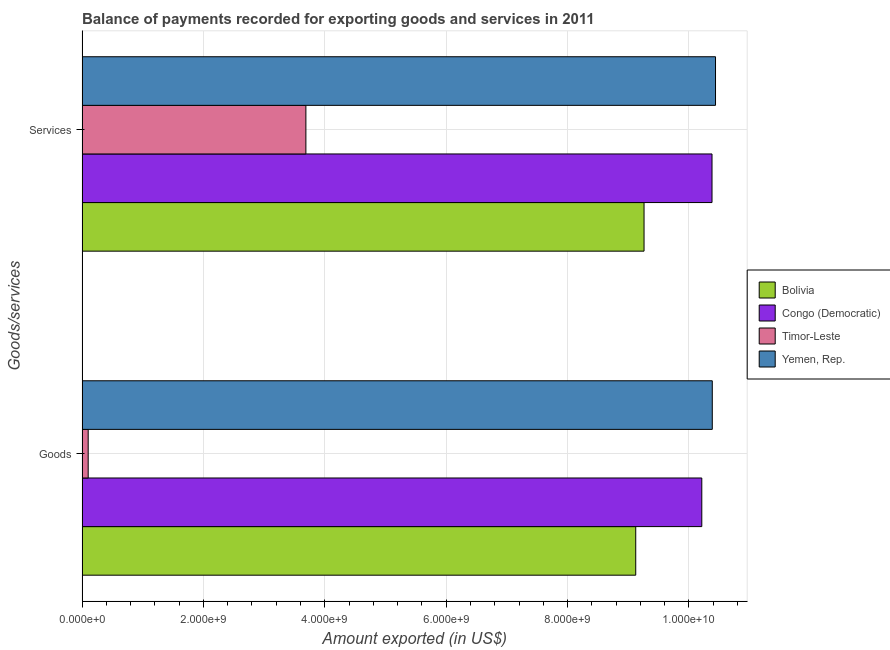How many bars are there on the 1st tick from the top?
Offer a terse response. 4. What is the label of the 2nd group of bars from the top?
Offer a terse response. Goods. What is the amount of services exported in Bolivia?
Ensure brevity in your answer.  9.26e+09. Across all countries, what is the maximum amount of services exported?
Your answer should be very brief. 1.04e+1. Across all countries, what is the minimum amount of services exported?
Your response must be concise. 3.69e+09. In which country was the amount of goods exported maximum?
Your response must be concise. Yemen, Rep. In which country was the amount of services exported minimum?
Offer a terse response. Timor-Leste. What is the total amount of goods exported in the graph?
Your answer should be compact. 2.98e+1. What is the difference between the amount of services exported in Bolivia and that in Timor-Leste?
Offer a terse response. 5.57e+09. What is the difference between the amount of services exported in Yemen, Rep. and the amount of goods exported in Bolivia?
Offer a terse response. 1.31e+09. What is the average amount of services exported per country?
Your response must be concise. 8.44e+09. What is the difference between the amount of services exported and amount of goods exported in Timor-Leste?
Make the answer very short. 3.59e+09. What is the ratio of the amount of services exported in Bolivia to that in Congo (Democratic)?
Your answer should be very brief. 0.89. In how many countries, is the amount of services exported greater than the average amount of services exported taken over all countries?
Make the answer very short. 3. What does the 4th bar from the top in Services represents?
Offer a very short reply. Bolivia. What does the 4th bar from the bottom in Goods represents?
Your answer should be very brief. Yemen, Rep. What is the difference between two consecutive major ticks on the X-axis?
Offer a terse response. 2.00e+09. Where does the legend appear in the graph?
Make the answer very short. Center right. How are the legend labels stacked?
Your answer should be compact. Vertical. What is the title of the graph?
Keep it short and to the point. Balance of payments recorded for exporting goods and services in 2011. Does "United Kingdom" appear as one of the legend labels in the graph?
Ensure brevity in your answer.  No. What is the label or title of the X-axis?
Your answer should be compact. Amount exported (in US$). What is the label or title of the Y-axis?
Your response must be concise. Goods/services. What is the Amount exported (in US$) in Bolivia in Goods?
Offer a terse response. 9.12e+09. What is the Amount exported (in US$) of Congo (Democratic) in Goods?
Your response must be concise. 1.02e+1. What is the Amount exported (in US$) of Timor-Leste in Goods?
Offer a terse response. 1.01e+08. What is the Amount exported (in US$) of Yemen, Rep. in Goods?
Provide a short and direct response. 1.04e+1. What is the Amount exported (in US$) of Bolivia in Services?
Make the answer very short. 9.26e+09. What is the Amount exported (in US$) of Congo (Democratic) in Services?
Your answer should be very brief. 1.04e+1. What is the Amount exported (in US$) in Timor-Leste in Services?
Keep it short and to the point. 3.69e+09. What is the Amount exported (in US$) of Yemen, Rep. in Services?
Provide a short and direct response. 1.04e+1. Across all Goods/services, what is the maximum Amount exported (in US$) of Bolivia?
Provide a short and direct response. 9.26e+09. Across all Goods/services, what is the maximum Amount exported (in US$) of Congo (Democratic)?
Your answer should be very brief. 1.04e+1. Across all Goods/services, what is the maximum Amount exported (in US$) of Timor-Leste?
Your response must be concise. 3.69e+09. Across all Goods/services, what is the maximum Amount exported (in US$) in Yemen, Rep.?
Your answer should be very brief. 1.04e+1. Across all Goods/services, what is the minimum Amount exported (in US$) in Bolivia?
Keep it short and to the point. 9.12e+09. Across all Goods/services, what is the minimum Amount exported (in US$) in Congo (Democratic)?
Your answer should be very brief. 1.02e+1. Across all Goods/services, what is the minimum Amount exported (in US$) in Timor-Leste?
Your response must be concise. 1.01e+08. Across all Goods/services, what is the minimum Amount exported (in US$) of Yemen, Rep.?
Your answer should be compact. 1.04e+1. What is the total Amount exported (in US$) of Bolivia in the graph?
Your answer should be very brief. 1.84e+1. What is the total Amount exported (in US$) in Congo (Democratic) in the graph?
Give a very brief answer. 2.06e+1. What is the total Amount exported (in US$) in Timor-Leste in the graph?
Your answer should be very brief. 3.79e+09. What is the total Amount exported (in US$) of Yemen, Rep. in the graph?
Ensure brevity in your answer.  2.08e+1. What is the difference between the Amount exported (in US$) in Bolivia in Goods and that in Services?
Ensure brevity in your answer.  -1.37e+08. What is the difference between the Amount exported (in US$) in Congo (Democratic) in Goods and that in Services?
Your response must be concise. -1.68e+08. What is the difference between the Amount exported (in US$) in Timor-Leste in Goods and that in Services?
Your response must be concise. -3.59e+09. What is the difference between the Amount exported (in US$) in Yemen, Rep. in Goods and that in Services?
Your response must be concise. -5.33e+07. What is the difference between the Amount exported (in US$) in Bolivia in Goods and the Amount exported (in US$) in Congo (Democratic) in Services?
Your answer should be very brief. -1.26e+09. What is the difference between the Amount exported (in US$) of Bolivia in Goods and the Amount exported (in US$) of Timor-Leste in Services?
Your answer should be compact. 5.43e+09. What is the difference between the Amount exported (in US$) of Bolivia in Goods and the Amount exported (in US$) of Yemen, Rep. in Services?
Your response must be concise. -1.31e+09. What is the difference between the Amount exported (in US$) of Congo (Democratic) in Goods and the Amount exported (in US$) of Timor-Leste in Services?
Your answer should be very brief. 6.52e+09. What is the difference between the Amount exported (in US$) of Congo (Democratic) in Goods and the Amount exported (in US$) of Yemen, Rep. in Services?
Your response must be concise. -2.26e+08. What is the difference between the Amount exported (in US$) in Timor-Leste in Goods and the Amount exported (in US$) in Yemen, Rep. in Services?
Offer a very short reply. -1.03e+1. What is the average Amount exported (in US$) of Bolivia per Goods/services?
Offer a terse response. 9.19e+09. What is the average Amount exported (in US$) of Congo (Democratic) per Goods/services?
Your answer should be compact. 1.03e+1. What is the average Amount exported (in US$) in Timor-Leste per Goods/services?
Offer a terse response. 1.89e+09. What is the average Amount exported (in US$) of Yemen, Rep. per Goods/services?
Your answer should be compact. 1.04e+1. What is the difference between the Amount exported (in US$) in Bolivia and Amount exported (in US$) in Congo (Democratic) in Goods?
Your response must be concise. -1.09e+09. What is the difference between the Amount exported (in US$) in Bolivia and Amount exported (in US$) in Timor-Leste in Goods?
Your response must be concise. 9.02e+09. What is the difference between the Amount exported (in US$) of Bolivia and Amount exported (in US$) of Yemen, Rep. in Goods?
Give a very brief answer. -1.26e+09. What is the difference between the Amount exported (in US$) of Congo (Democratic) and Amount exported (in US$) of Timor-Leste in Goods?
Make the answer very short. 1.01e+1. What is the difference between the Amount exported (in US$) in Congo (Democratic) and Amount exported (in US$) in Yemen, Rep. in Goods?
Provide a short and direct response. -1.73e+08. What is the difference between the Amount exported (in US$) of Timor-Leste and Amount exported (in US$) of Yemen, Rep. in Goods?
Give a very brief answer. -1.03e+1. What is the difference between the Amount exported (in US$) of Bolivia and Amount exported (in US$) of Congo (Democratic) in Services?
Provide a succinct answer. -1.12e+09. What is the difference between the Amount exported (in US$) in Bolivia and Amount exported (in US$) in Timor-Leste in Services?
Provide a short and direct response. 5.57e+09. What is the difference between the Amount exported (in US$) in Bolivia and Amount exported (in US$) in Yemen, Rep. in Services?
Keep it short and to the point. -1.18e+09. What is the difference between the Amount exported (in US$) of Congo (Democratic) and Amount exported (in US$) of Timor-Leste in Services?
Provide a succinct answer. 6.69e+09. What is the difference between the Amount exported (in US$) of Congo (Democratic) and Amount exported (in US$) of Yemen, Rep. in Services?
Offer a very short reply. -5.78e+07. What is the difference between the Amount exported (in US$) in Timor-Leste and Amount exported (in US$) in Yemen, Rep. in Services?
Provide a succinct answer. -6.75e+09. What is the ratio of the Amount exported (in US$) of Bolivia in Goods to that in Services?
Provide a short and direct response. 0.99. What is the ratio of the Amount exported (in US$) in Congo (Democratic) in Goods to that in Services?
Give a very brief answer. 0.98. What is the ratio of the Amount exported (in US$) in Timor-Leste in Goods to that in Services?
Provide a short and direct response. 0.03. What is the ratio of the Amount exported (in US$) in Yemen, Rep. in Goods to that in Services?
Your response must be concise. 0.99. What is the difference between the highest and the second highest Amount exported (in US$) of Bolivia?
Your response must be concise. 1.37e+08. What is the difference between the highest and the second highest Amount exported (in US$) in Congo (Democratic)?
Keep it short and to the point. 1.68e+08. What is the difference between the highest and the second highest Amount exported (in US$) in Timor-Leste?
Provide a succinct answer. 3.59e+09. What is the difference between the highest and the second highest Amount exported (in US$) of Yemen, Rep.?
Your answer should be compact. 5.33e+07. What is the difference between the highest and the lowest Amount exported (in US$) of Bolivia?
Provide a succinct answer. 1.37e+08. What is the difference between the highest and the lowest Amount exported (in US$) in Congo (Democratic)?
Provide a succinct answer. 1.68e+08. What is the difference between the highest and the lowest Amount exported (in US$) in Timor-Leste?
Make the answer very short. 3.59e+09. What is the difference between the highest and the lowest Amount exported (in US$) of Yemen, Rep.?
Offer a very short reply. 5.33e+07. 